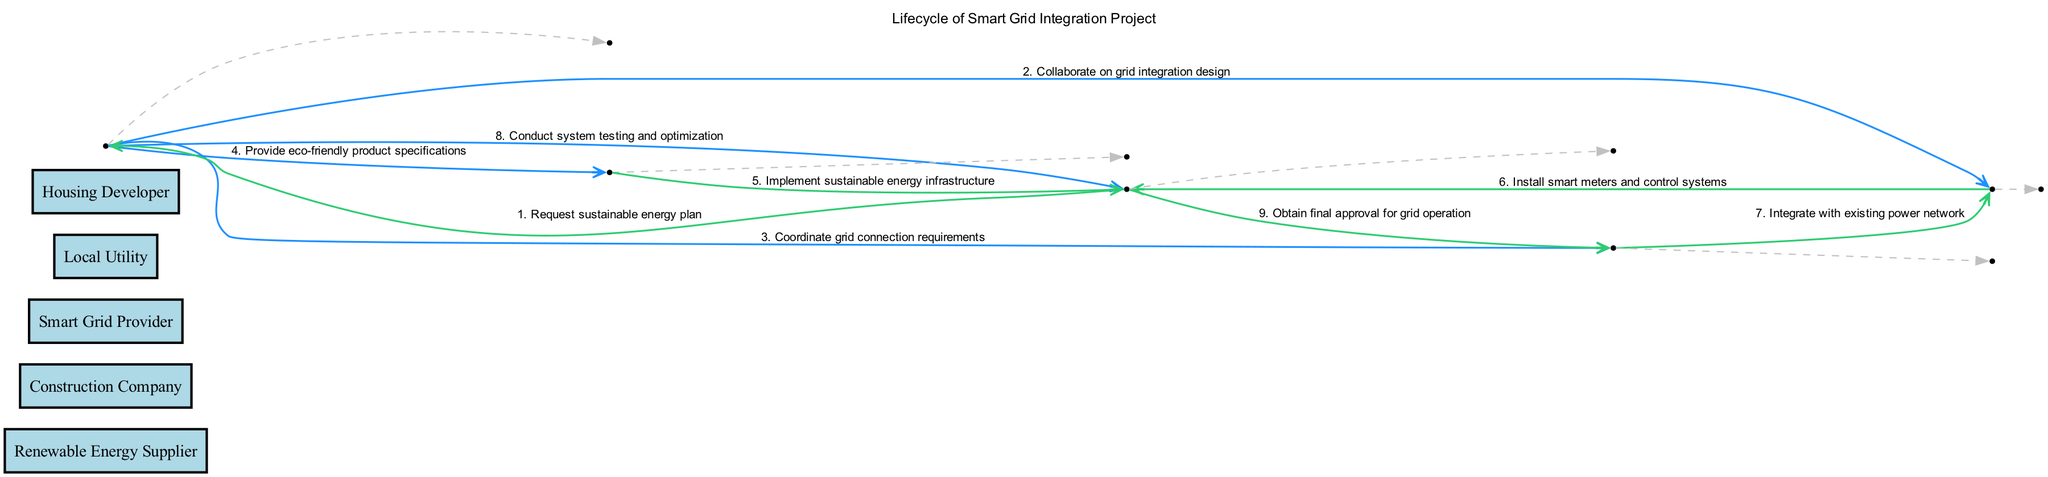What is the first step in the sequence diagram? The first step in the sequence diagram is initiated by the Housing Developer who requests a sustainable energy plan from the Renewable Energy Supplier.
Answer: Request sustainable energy plan Which actor corresponds to the last message in the sequence? The last message in the sequence is "Obtain final approval for grid operation," which is sent from Housing Developer to Local Utility, indicating that the Local Utility is the actor involved in the last message.
Answer: Local Utility How many total messages are exchanged between actors in the diagram? By counting the messages listed in the sequence, there are 9 total messages exchanged between actors in the diagram.
Answer: 9 Which actor provides eco-friendly product specifications? The message "Provide eco-friendly product specifications" is sent from the Renewable Energy Supplier to the Construction Company, indicating that the Renewable Energy Supplier is the actor providing these specifications.
Answer: Renewable Energy Supplier What role does the Smart Grid Provider play in the sequence? The Smart Grid Provider's role includes collaborating on the grid integration design and installing smart meters and control systems for the Housing Developer, indicating a dual role in both planning and implementation within the project.
Answer: Collaborate and install Which two actors collaborate on grid integration design? The Renewable Energy Supplier and the Smart Grid Provider collaborate on grid integration design as shown by the message exchanged between them in the sequence diagram.
Answer: Renewable Energy Supplier, Smart Grid Provider What does the Housing Developer need to do after implementing infrastructure? After implementing the sustainable energy infrastructure, the Housing Developer must obtain final approval for grid operation from the Local Utility, indicating an important regulatory step before operations can commence.
Answer: Obtain final approval for grid operation How many actors are involved in the diagram? There are 5 actors involved in the diagram: Renewable Energy Supplier, Construction Company, Smart Grid Provider, Local Utility, and Housing Developer.
Answer: 5 What type of systems does the Smart Grid Provider install? The Smart Grid Provider installs smart meters and control systems, as indicated by the message directed from the Smart Grid Provider to the Housing Developer.
Answer: Smart meters and control systems 